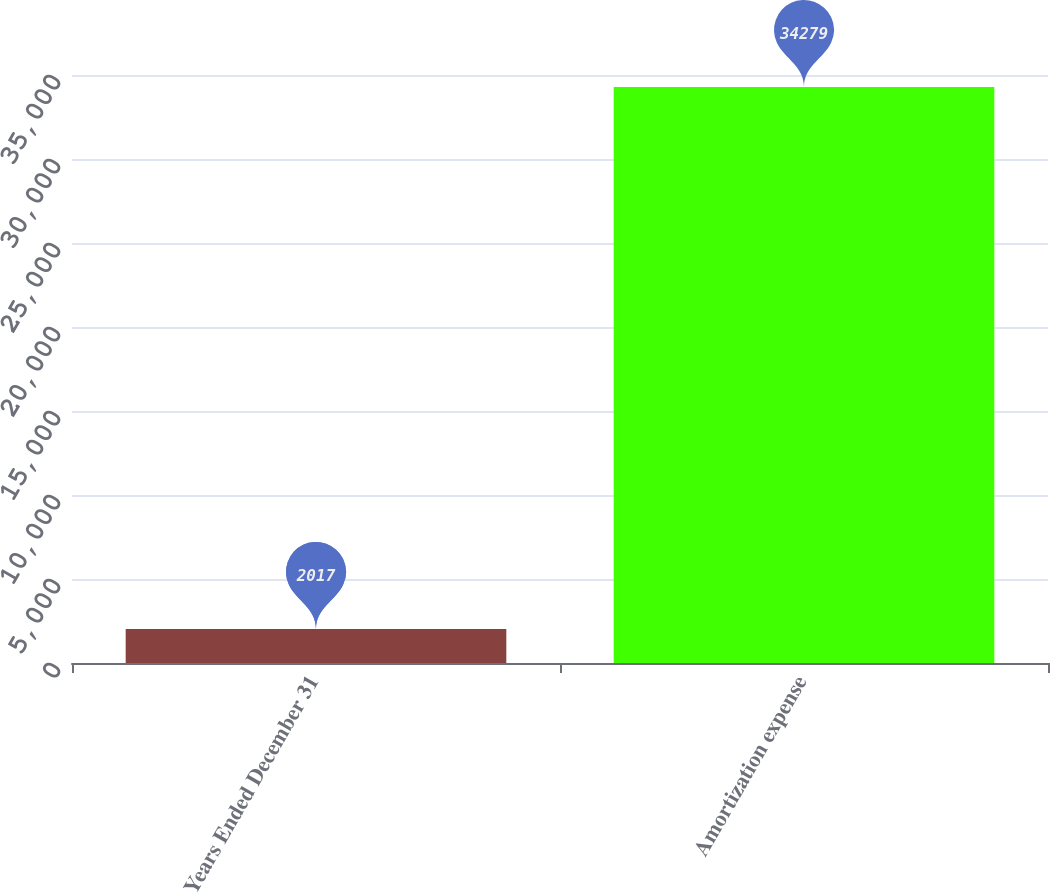<chart> <loc_0><loc_0><loc_500><loc_500><bar_chart><fcel>Years Ended December 31<fcel>Amortization expense<nl><fcel>2017<fcel>34279<nl></chart> 